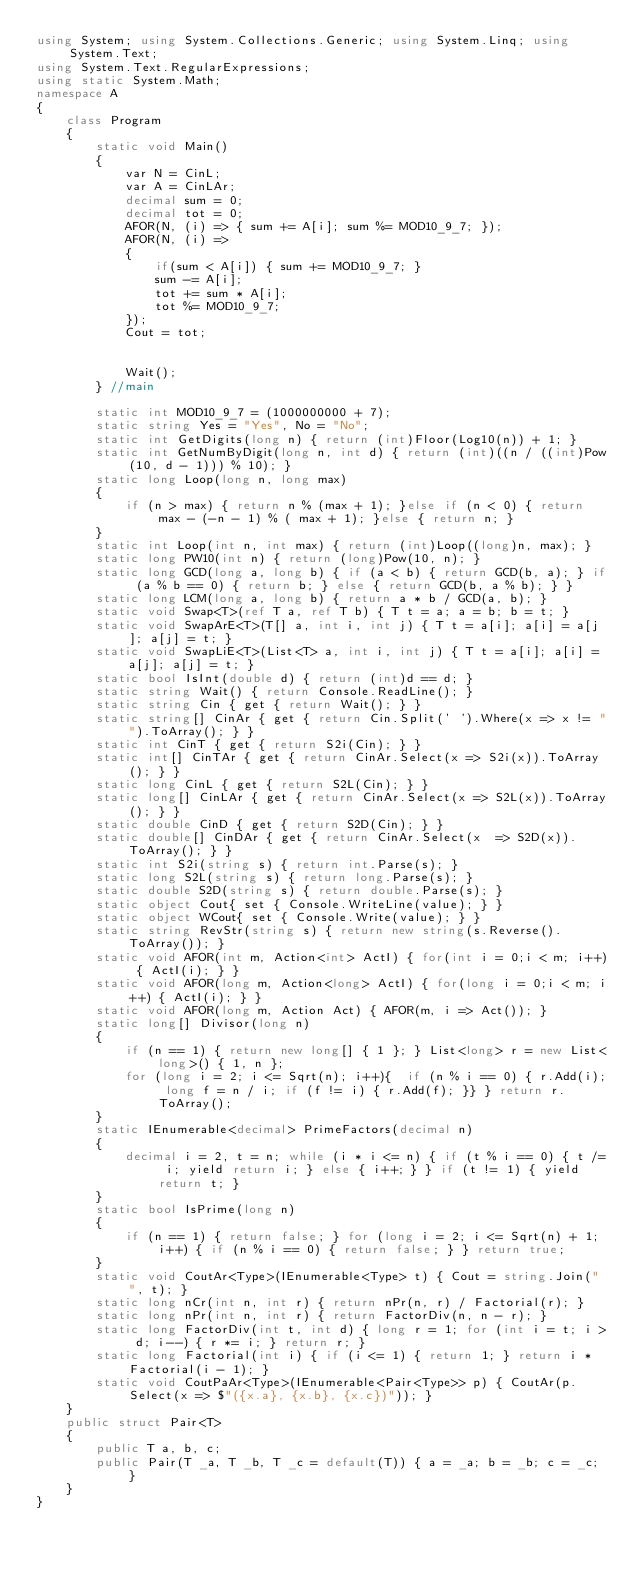Convert code to text. <code><loc_0><loc_0><loc_500><loc_500><_C#_>using System; using System.Collections.Generic; using System.Linq; using System.Text;
using System.Text.RegularExpressions;
using static System.Math;
namespace A
{
    class Program
    {
        static void Main()
        {
            var N = CinL;
            var A = CinLAr;
            decimal sum = 0;
            decimal tot = 0;
            AFOR(N, (i) => { sum += A[i]; sum %= MOD10_9_7; });
            AFOR(N, (i) =>
            {
                if(sum < A[i]) { sum += MOD10_9_7; }
                sum -= A[i];
                tot += sum * A[i];
                tot %= MOD10_9_7;
            });
            Cout = tot;


            Wait();
        } //main

        static int MOD10_9_7 = (1000000000 + 7);
        static string Yes = "Yes", No = "No";
        static int GetDigits(long n) { return (int)Floor(Log10(n)) + 1; }
        static int GetNumByDigit(long n, int d) { return (int)((n / ((int)Pow(10, d - 1))) % 10); }
        static long Loop(long n, long max)
        {
            if (n > max) { return n % (max + 1); }else if (n < 0) { return  max - (-n - 1) % ( max + 1); }else { return n; }
        }
        static int Loop(int n, int max) { return (int)Loop((long)n, max); }
        static long PW10(int n) { return (long)Pow(10, n); }
        static long GCD(long a, long b) { if (a < b) { return GCD(b, a); } if (a % b == 0) { return b; } else { return GCD(b, a % b); } }
        static long LCM(long a, long b) { return a * b / GCD(a, b); }
        static void Swap<T>(ref T a, ref T b) { T t = a; a = b; b = t; }
        static void SwapArE<T>(T[] a, int i, int j) { T t = a[i]; a[i] = a[j]; a[j] = t; }
        static void SwapLiE<T>(List<T> a, int i, int j) { T t = a[i]; a[i] = a[j]; a[j] = t; }
        static bool IsInt(double d) { return (int)d == d; }
        static string Wait() { return Console.ReadLine(); }
        static string Cin { get { return Wait(); } }
        static string[] CinAr { get { return Cin.Split(' ').Where(x => x != "").ToArray(); } }
        static int CinT { get { return S2i(Cin); } }
        static int[] CinTAr { get { return CinAr.Select(x => S2i(x)).ToArray(); } }
        static long CinL { get { return S2L(Cin); } }
        static long[] CinLAr { get { return CinAr.Select(x => S2L(x)).ToArray(); } }
        static double CinD { get { return S2D(Cin); } }
        static double[] CinDAr { get { return CinAr.Select(x  => S2D(x)).ToArray(); } }
        static int S2i(string s) { return int.Parse(s); }
        static long S2L(string s) { return long.Parse(s); }
        static double S2D(string s) { return double.Parse(s); }
        static object Cout{ set { Console.WriteLine(value); } }
        static object WCout{ set { Console.Write(value); } }
        static string RevStr(string s) { return new string(s.Reverse().ToArray()); }
        static void AFOR(int m, Action<int> ActI) { for(int i = 0;i < m; i++) { ActI(i); } }
        static void AFOR(long m, Action<long> ActI) { for(long i = 0;i < m; i++) { ActI(i); } }
        static void AFOR(long m, Action Act) { AFOR(m, i => Act()); }
        static long[] Divisor(long n)
        {
            if (n == 1) { return new long[] { 1 }; } List<long> r = new List<long>() { 1, n };
            for (long i = 2; i <= Sqrt(n); i++){  if (n % i == 0) { r.Add(i); long f = n / i; if (f != i) { r.Add(f); }} } return r.ToArray();
        }
        static IEnumerable<decimal> PrimeFactors(decimal n)
        {
            decimal i = 2, t = n; while (i * i <= n) { if (t % i == 0) { t /= i; yield return i; } else { i++; } } if (t != 1) { yield return t; }
        }
        static bool IsPrime(long n)
        {
            if (n == 1) { return false; } for (long i = 2; i <= Sqrt(n) + 1; i++) { if (n % i == 0) { return false; } } return true;
        }
        static void CoutAr<Type>(IEnumerable<Type> t) { Cout = string.Join(" ", t); }
        static long nCr(int n, int r) { return nPr(n, r) / Factorial(r); }
        static long nPr(int n, int r) { return FactorDiv(n, n - r); }
        static long FactorDiv(int t, int d) { long r = 1; for (int i = t; i > d; i--) { r *= i; } return r; }
        static long Factorial(int i) { if (i <= 1) { return 1; } return i * Factorial(i - 1); }
        static void CoutPaAr<Type>(IEnumerable<Pair<Type>> p) { CoutAr(p.Select(x => $"({x.a}, {x.b}, {x.c})")); }
    }
    public struct Pair<T>
    {
        public T a, b, c;
        public Pair(T _a, T _b, T _c = default(T)) { a = _a; b = _b; c = _c; }
    }
}</code> 